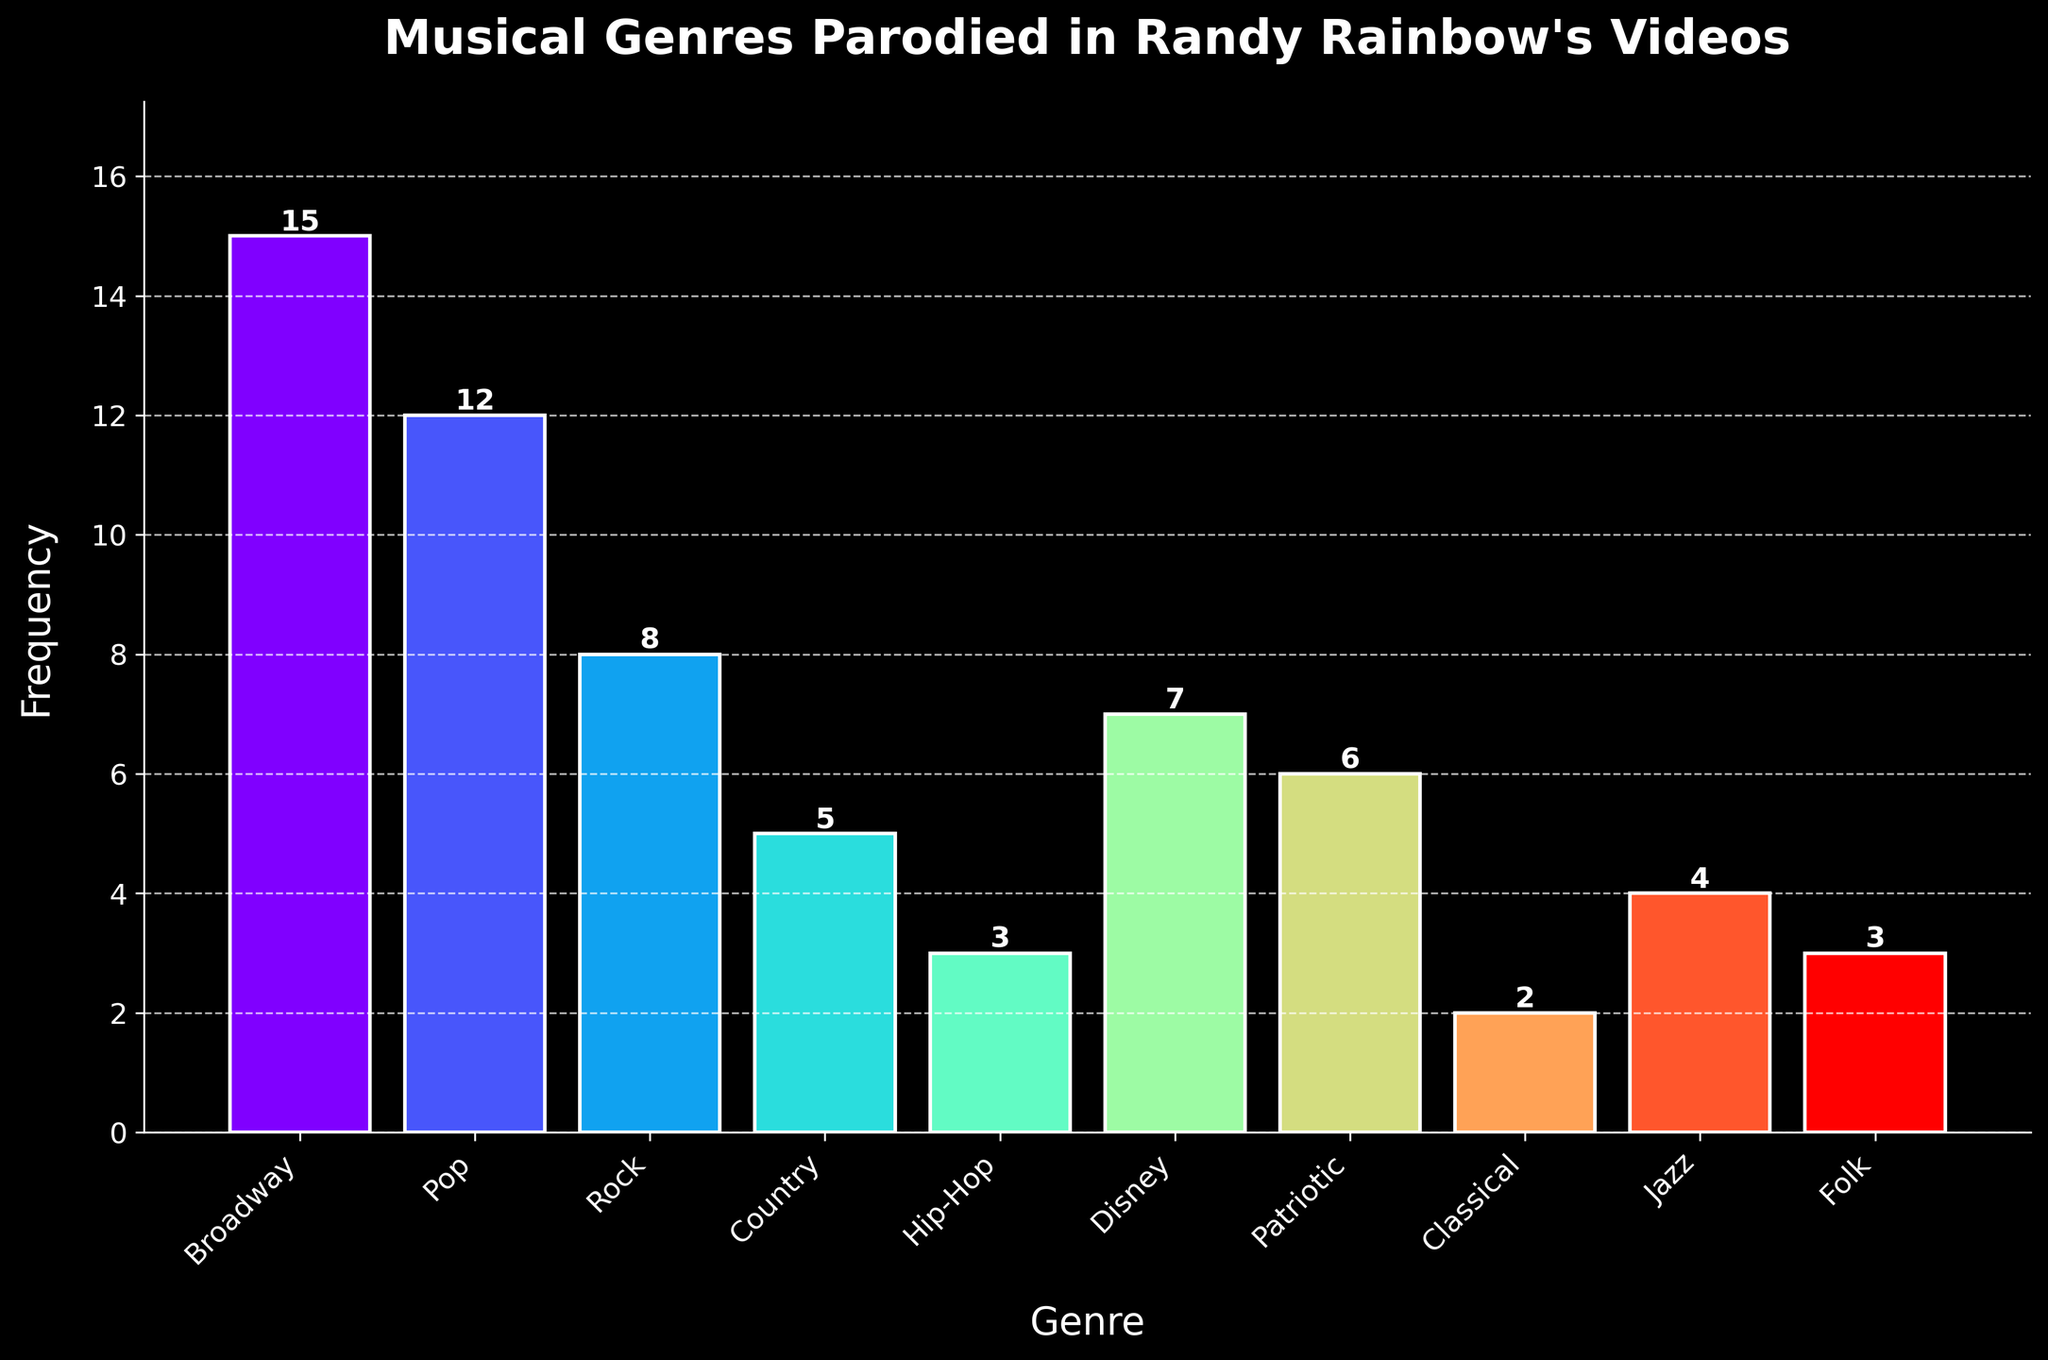What's the title of the figure? The title of the figure is usually at the top, centered above the plot. It gives a brief summary of what the figure represents.
Answer: Musical Genres Parodied in Randy Rainbow's Videos What are the labels of the x-axis and y-axis? The x-axis label is found below the horizontal axis, and the y-axis label is found beside the vertical axis. They briefly summarize what data each axis represents.
Answer: x-axis: Genre, y-axis: Frequency Which musical genre has the highest frequency? To find this, look for the tallest bar in the histogram and see which genre it corresponds to on the x-axis.
Answer: Broadway How many genres are parodied more than 10 times? Identify all the bars with heights greater than 10 by comparing them to the y-axis, then count these bars. There are two such genres: Broadway and Pop.
Answer: 2 What's the total frequency of the 'Disney' and 'Patriotic' genres? Identify the frequencies of 'Disney' (7) and 'Patriotic' (6) from the bars, then sum them up: 7 + 6 = 13.
Answer: 13 Which genre has the lowest frequency? Find the shortest bar in the histogram and see which genre it corresponds to on the x-axis.
Answer: Classical Is the frequency of 'Rock' greater than that of 'Disney'? Compare the height of the 'Rock' bar (8) to the height of the 'Disney' bar (7).
Answer: Yes What's the combined frequency of 'Hip-Hop' and 'Folk' genres? Identify the frequencies of 'Hip-Hop' (3) and 'Folk' (3) from the bars, then sum them up: 3 + 3 = 6.
Answer: 6 What is the median frequency of all listed musical genres? First, list all the frequencies in ascending order: 2, 3, 3, 4, 5, 6, 7, 8, 12, 15. As there are 10 values, the median will be the average of the 5th and 6th values: (5 + 6) / 2 = 5.5.
Answer: 5.5 How does the frequency of 'Jazz' compare to 'Country'? Identify the heights of the 'Jazz' (4) and 'Country' (5) bars, then compare them.
Answer: Jazz is less frequent than Country 